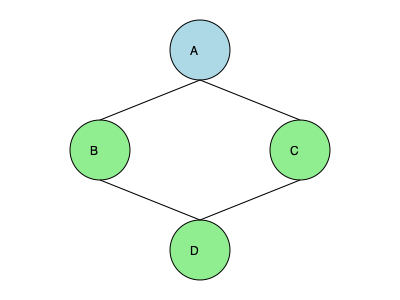In the distributed system topology shown above, node A is the primary node that processes incoming requests. If the system implements a load balancing strategy where node A distributes incoming requests equally among nodes B, C, and D, what is the probability that a request will be processed by node C? To solve this problem, we need to follow these steps:

1. Identify the key components of the system:
   - Node A is the primary node that receives and distributes requests.
   - Nodes B, C, and D are secondary nodes that process the distributed requests.

2. Understand the load balancing strategy:
   - Node A distributes incoming requests equally among nodes B, C, and D.
   - This means each secondary node has an equal chance of receiving a request.

3. Calculate the probability:
   - There are 3 secondary nodes (B, C, and D) that can receive requests.
   - The requests are distributed equally, so each node has an equal probability of receiving a request.
   - The probability of a request being sent to any specific node is $\frac{1}{3}$.

4. Conclusion:
   - Since we're asked about the probability of a request being processed by node C specifically, and node C has a $\frac{1}{3}$ chance of receiving any given request, the probability is $\frac{1}{3}$.

In mathematical notation, we can express this as:

$$ P(\text{request processed by node C}) = \frac{1}{3} $$

This probability assumes that the load balancing is perfect and that all nodes are functioning correctly.
Answer: $\frac{1}{3}$ 